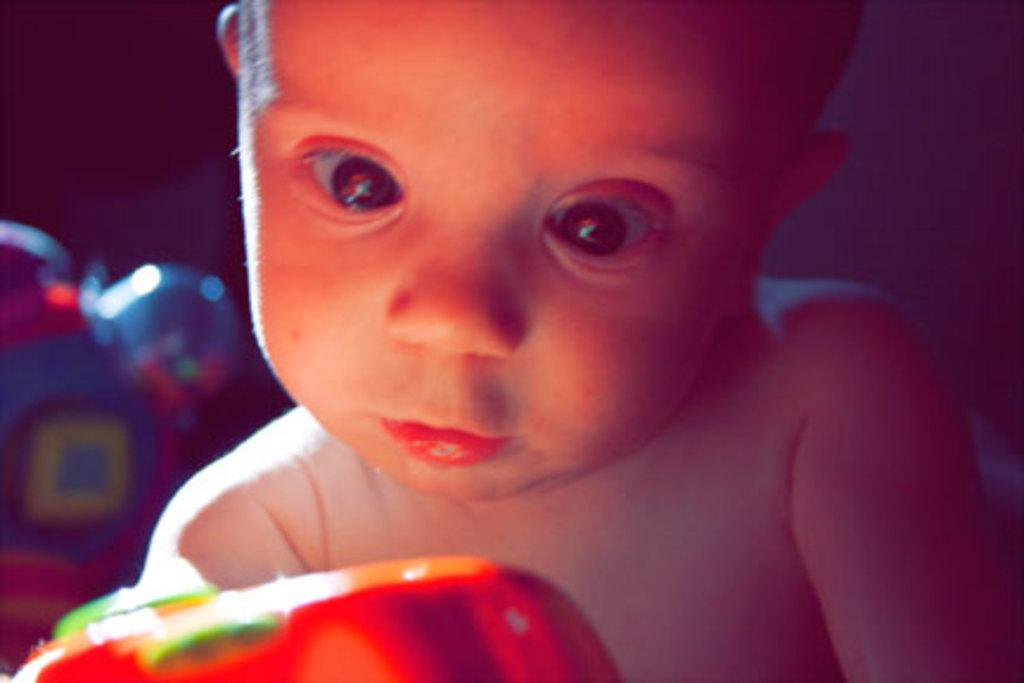What is the main subject of the image? The main subject of the image is a baby. What else can be seen in the image besides the baby? There are two toys in the background of the image. What type of record can be seen being played by the baby in the image? There is no record present in the image, and the baby is not playing any record. 